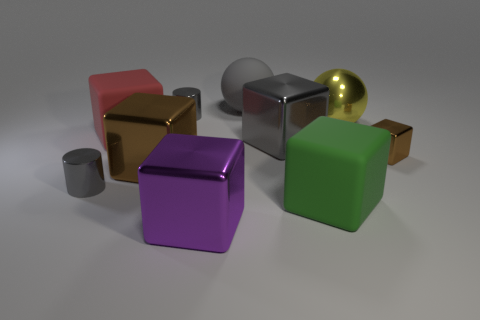How many big yellow things have the same shape as the gray matte thing?
Give a very brief answer. 1. There is a large matte block that is left of the large gray ball; what color is it?
Ensure brevity in your answer.  Red. How many metallic things are cylinders or big yellow cylinders?
Make the answer very short. 2. There is a large thing that is the same color as the rubber sphere; what is its shape?
Provide a short and direct response. Cube. What number of rubber spheres have the same size as the purple block?
Offer a terse response. 1. There is a object that is both on the right side of the big green block and in front of the yellow thing; what color is it?
Provide a short and direct response. Brown. How many things are green matte cylinders or yellow metallic things?
Provide a short and direct response. 1. What number of small things are either brown shiny spheres or gray metallic cubes?
Your answer should be compact. 0. Are there any other things of the same color as the shiny sphere?
Make the answer very short. No. How big is the gray metal thing that is on the left side of the big gray ball and in front of the large red object?
Provide a short and direct response. Small. 